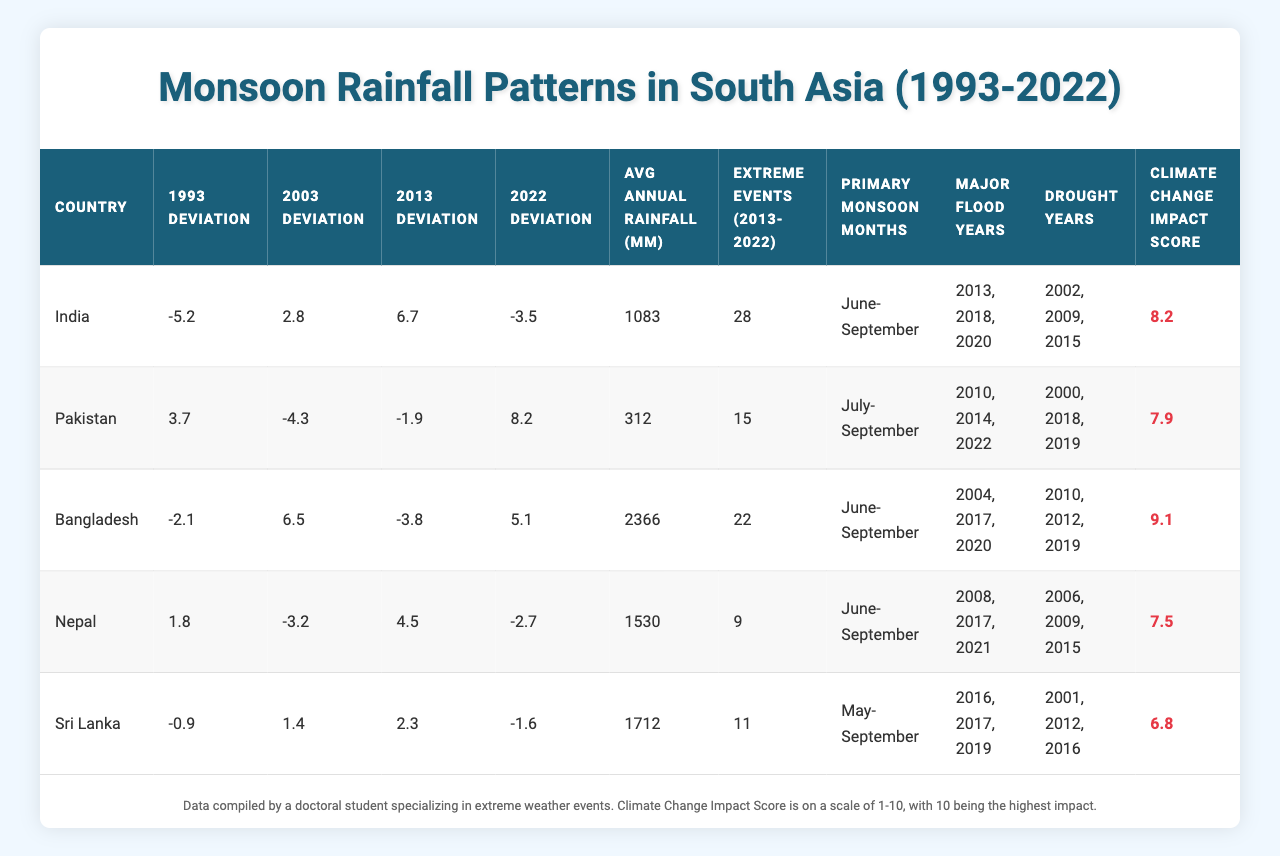What country had the highest average annual rainfall? By looking at the "Avg Annual Rainfall (mm)" column, Bangladesh has the highest value of 2366 mm.
Answer: Bangladesh In which year did India experience the highest deviation in monsoon rainfall? From the "Deviation" columns, India's highest deviation is in 2013 at 6.7.
Answer: 2013 How many extreme events did Pakistan experience between 2013 and 2022? The table shows that Pakistan had 15 extreme events in that period.
Answer: 15 Was there a drought year recorded for Sri Lanka in 2016? Yes, Sri Lanka's "Drought Years" column lists 2016 as one of its drought years.
Answer: Yes Which country had the largest positive deviation from historical averages in 2022? The "2022 Deviation" column shows that Pakistan had the highest positive deviation at 8.2.
Answer: Pakistan What is the average impact score of climate change for the five countries listed? The average of the "Climate Change Impact Score" values (8.2 + 7.9 + 9.1 + 7.5 + 6.8) is 7.9; calculated as 39.5/5 = 7.9.
Answer: 7.9 How many countries had a negative deviation in 1993? Checking the "1993 Deviation" column, India, Bangladesh, and Sri Lanka have negative values, making it 3 countries.
Answer: 3 What is the total number of drought years across all countries? Summing the number of drought years from each country (3 for India, 3 for Pakistan, 3 for Bangladesh, 3 for Nepal, and 3 for Sri Lanka) equals 15.
Answer: 15 Which country had the lowest Climate Change Impact Score? Looking at the "Climate Change Impact Score," Sri Lanka has the lowest score of 6.8.
Answer: Sri Lanka Did Nepal experience more extreme events than India from 2013 to 2022? Nepal had 9 extreme events, while India had 28, so no.
Answer: No 